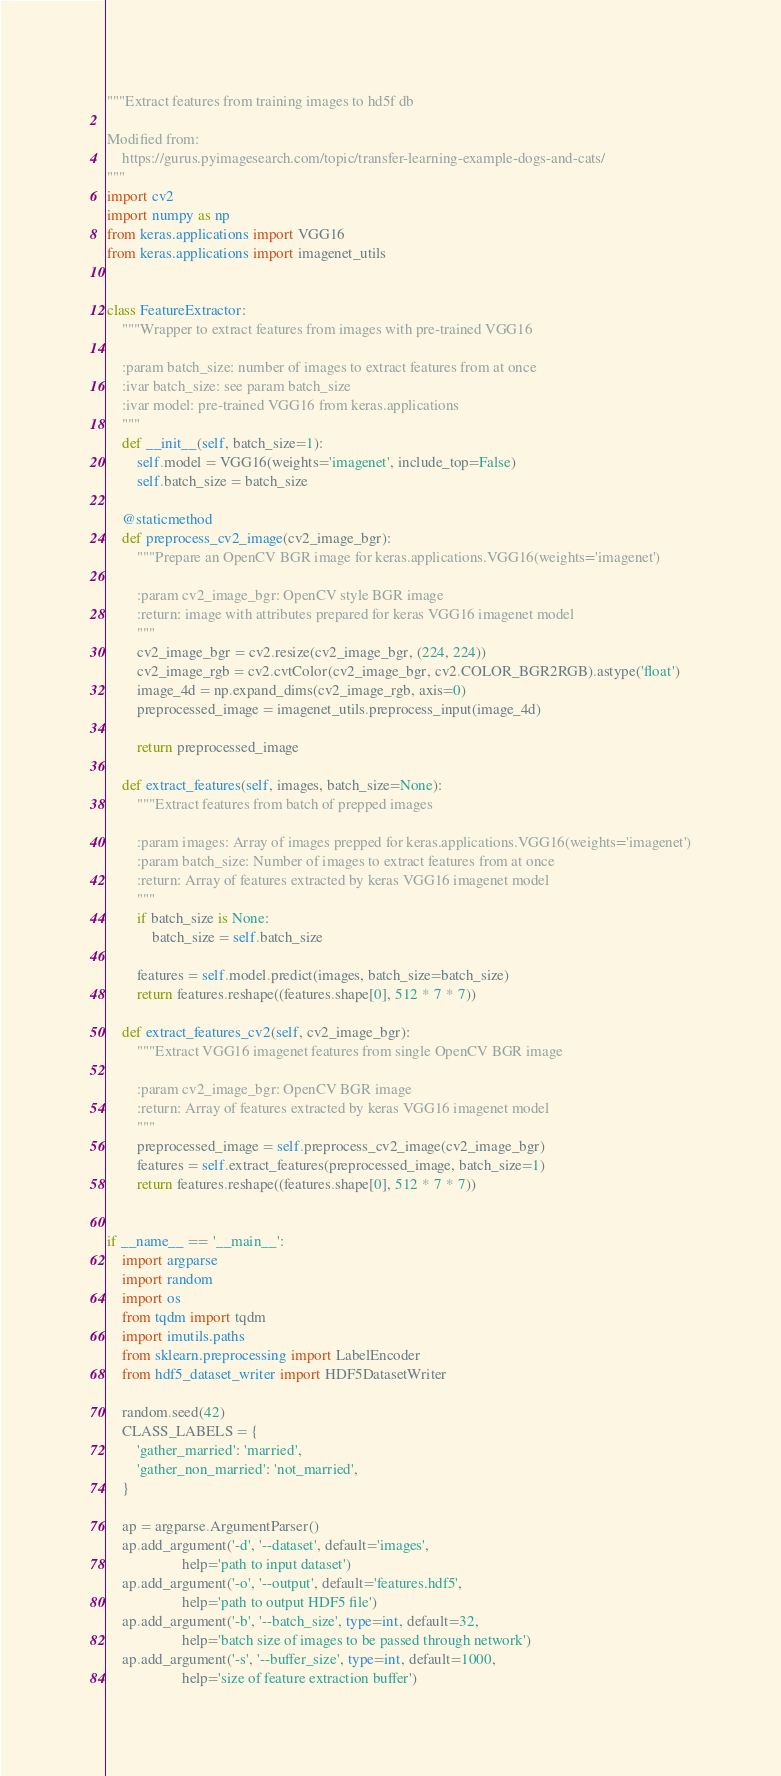<code> <loc_0><loc_0><loc_500><loc_500><_Python_>"""Extract features from training images to hd5f db

Modified from:
    https://gurus.pyimagesearch.com/topic/transfer-learning-example-dogs-and-cats/
"""
import cv2
import numpy as np
from keras.applications import VGG16
from keras.applications import imagenet_utils


class FeatureExtractor:
    """Wrapper to extract features from images with pre-trained VGG16

    :param batch_size: number of images to extract features from at once
    :ivar batch_size: see param batch_size
    :ivar model: pre-trained VGG16 from keras.applications
    """
    def __init__(self, batch_size=1):
        self.model = VGG16(weights='imagenet', include_top=False)
        self.batch_size = batch_size

    @staticmethod
    def preprocess_cv2_image(cv2_image_bgr):
        """Prepare an OpenCV BGR image for keras.applications.VGG16(weights='imagenet')

        :param cv2_image_bgr: OpenCV style BGR image
        :return: image with attributes prepared for keras VGG16 imagenet model
        """
        cv2_image_bgr = cv2.resize(cv2_image_bgr, (224, 224))
        cv2_image_rgb = cv2.cvtColor(cv2_image_bgr, cv2.COLOR_BGR2RGB).astype('float')
        image_4d = np.expand_dims(cv2_image_rgb, axis=0)
        preprocessed_image = imagenet_utils.preprocess_input(image_4d)

        return preprocessed_image

    def extract_features(self, images, batch_size=None):
        """Extract features from batch of prepped images

        :param images: Array of images prepped for keras.applications.VGG16(weights='imagenet')
        :param batch_size: Number of images to extract features from at once
        :return: Array of features extracted by keras VGG16 imagenet model
        """
        if batch_size is None:
            batch_size = self.batch_size

        features = self.model.predict(images, batch_size=batch_size)
        return features.reshape((features.shape[0], 512 * 7 * 7))

    def extract_features_cv2(self, cv2_image_bgr):
        """Extract VGG16 imagenet features from single OpenCV BGR image

        :param cv2_image_bgr: OpenCV BGR image
        :return: Array of features extracted by keras VGG16 imagenet model
        """
        preprocessed_image = self.preprocess_cv2_image(cv2_image_bgr)
        features = self.extract_features(preprocessed_image, batch_size=1)
        return features.reshape((features.shape[0], 512 * 7 * 7))


if __name__ == '__main__':
    import argparse
    import random
    import os
    from tqdm import tqdm
    import imutils.paths
    from sklearn.preprocessing import LabelEncoder
    from hdf5_dataset_writer import HDF5DatasetWriter

    random.seed(42)
    CLASS_LABELS = {
        'gather_married': 'married',
        'gather_non_married': 'not_married',
    }

    ap = argparse.ArgumentParser()
    ap.add_argument('-d', '--dataset', default='images',
                    help='path to input dataset')
    ap.add_argument('-o', '--output', default='features.hdf5',
                    help='path to output HDF5 file')
    ap.add_argument('-b', '--batch_size', type=int, default=32,
                    help='batch size of images to be passed through network')
    ap.add_argument('-s', '--buffer_size', type=int, default=1000,
                    help='size of feature extraction buffer')</code> 